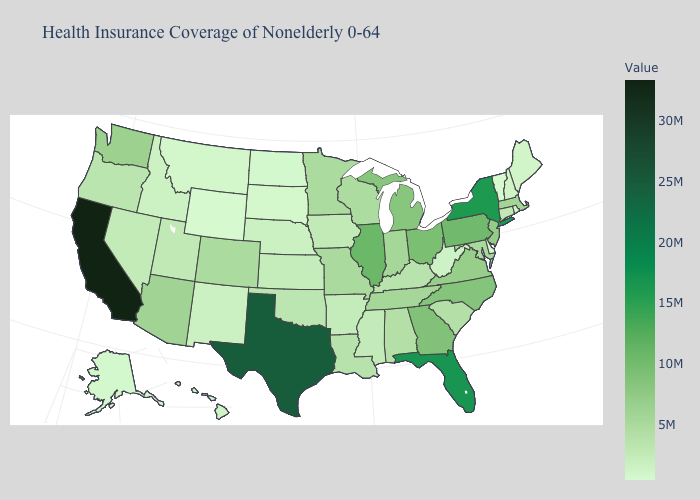Among the states that border Alabama , which have the lowest value?
Be succinct. Mississippi. Does Illinois have the highest value in the MidWest?
Quick response, please. Yes. Among the states that border New York , does Pennsylvania have the highest value?
Concise answer only. Yes. Which states have the lowest value in the USA?
Short answer required. Wyoming. Among the states that border Indiana , does Illinois have the lowest value?
Concise answer only. No. 